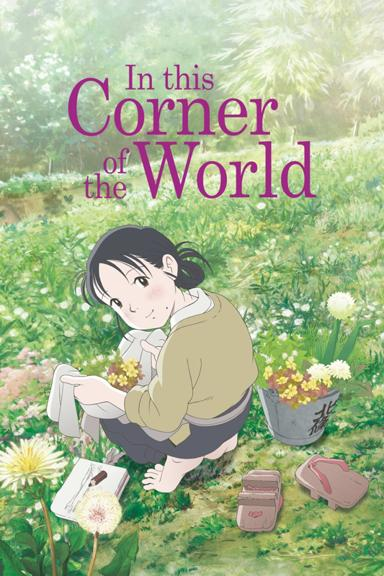Can you describe the girl's surroundings in the image? The girl is seated comfortably on a lush, green patch of grass. Around her, the area is vibrant with a variety of wildflowers in full bloom, creating a colorful and peaceful natural setting. Sunlight filters through the leaves of nearby trees, adding a warm, serene glow to the scene. 